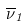Convert formula to latex. <formula><loc_0><loc_0><loc_500><loc_500>\overline { \nu } _ { 1 }</formula> 